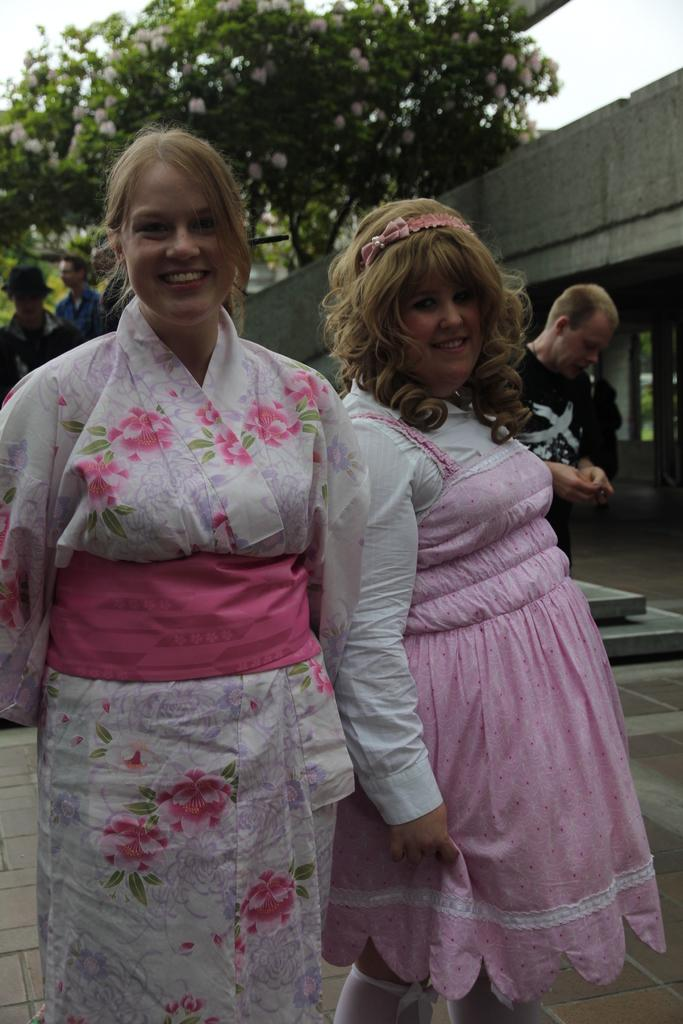Who or what is present in the image? There are people in the image. What can be seen beneath the people's feet? The ground is visible in the image. What type of vegetation is present in the image? There are trees with flowers in the image. What is located on the top right of the image? There is a wall on the top right of the image. What is visible above the wall and trees? The sky is visible in the image. How many rabbits can be seen hopping on the street in the image? There are no rabbits or streets present in the image. What finger is the person using to point at the sky in the image? There is no person pointing at the sky in the image, and no fingers are visible. 